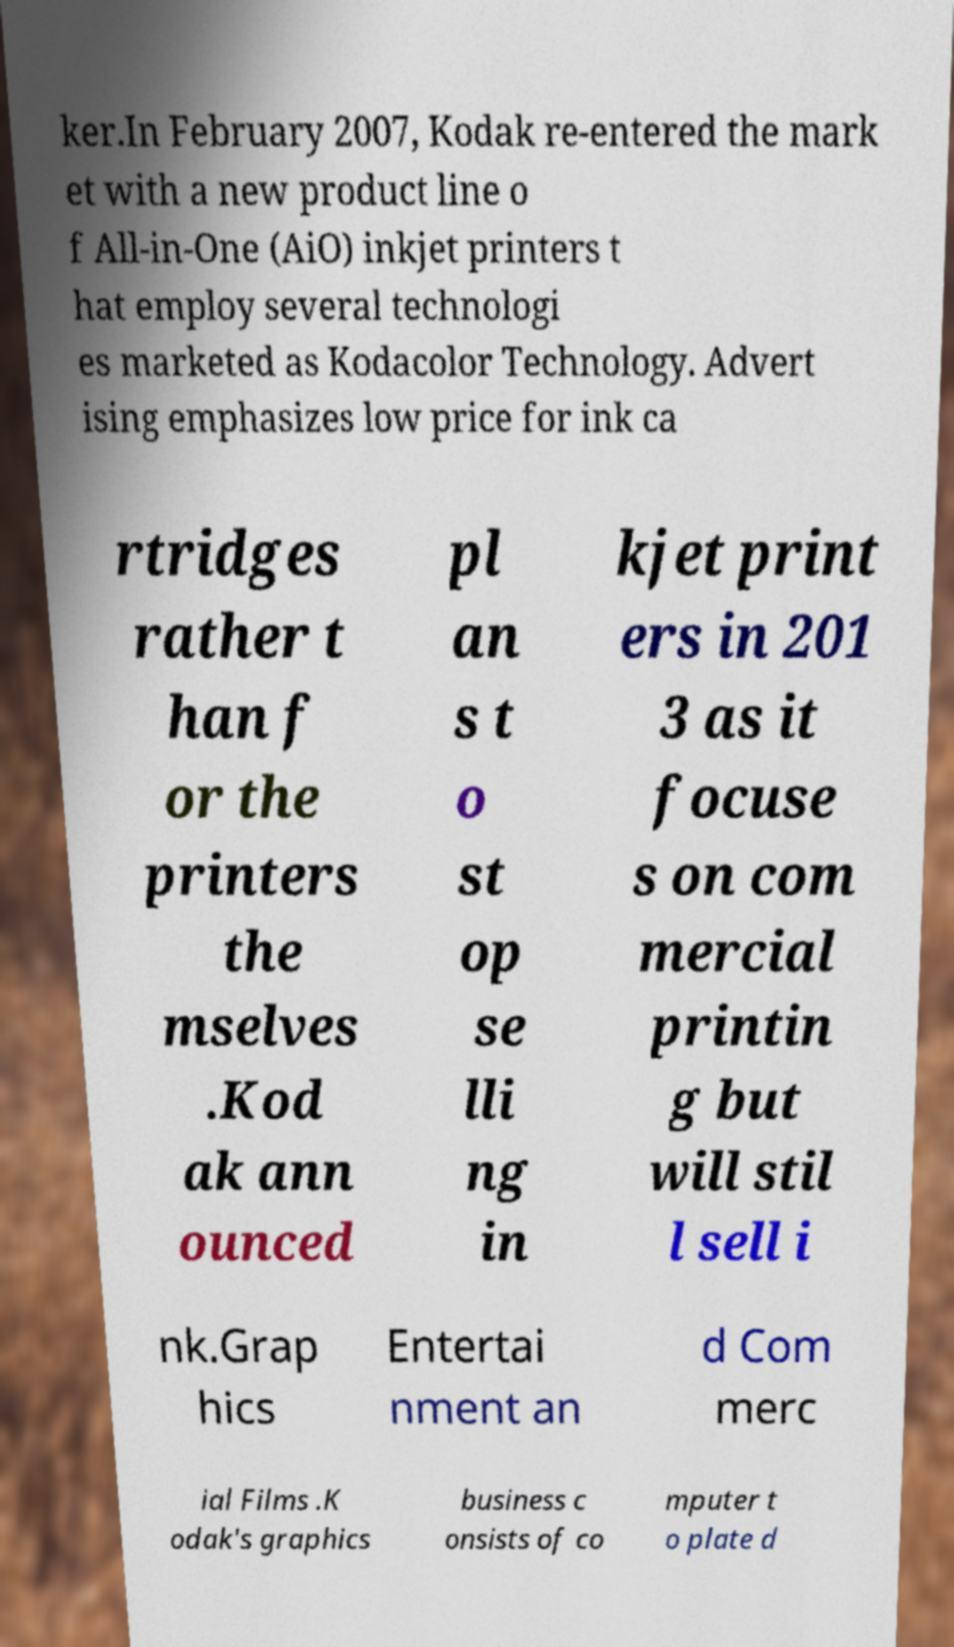What messages or text are displayed in this image? I need them in a readable, typed format. ker.In February 2007, Kodak re-entered the mark et with a new product line o f All-in-One (AiO) inkjet printers t hat employ several technologi es marketed as Kodacolor Technology. Advert ising emphasizes low price for ink ca rtridges rather t han f or the printers the mselves .Kod ak ann ounced pl an s t o st op se lli ng in kjet print ers in 201 3 as it focuse s on com mercial printin g but will stil l sell i nk.Grap hics Entertai nment an d Com merc ial Films .K odak's graphics business c onsists of co mputer t o plate d 